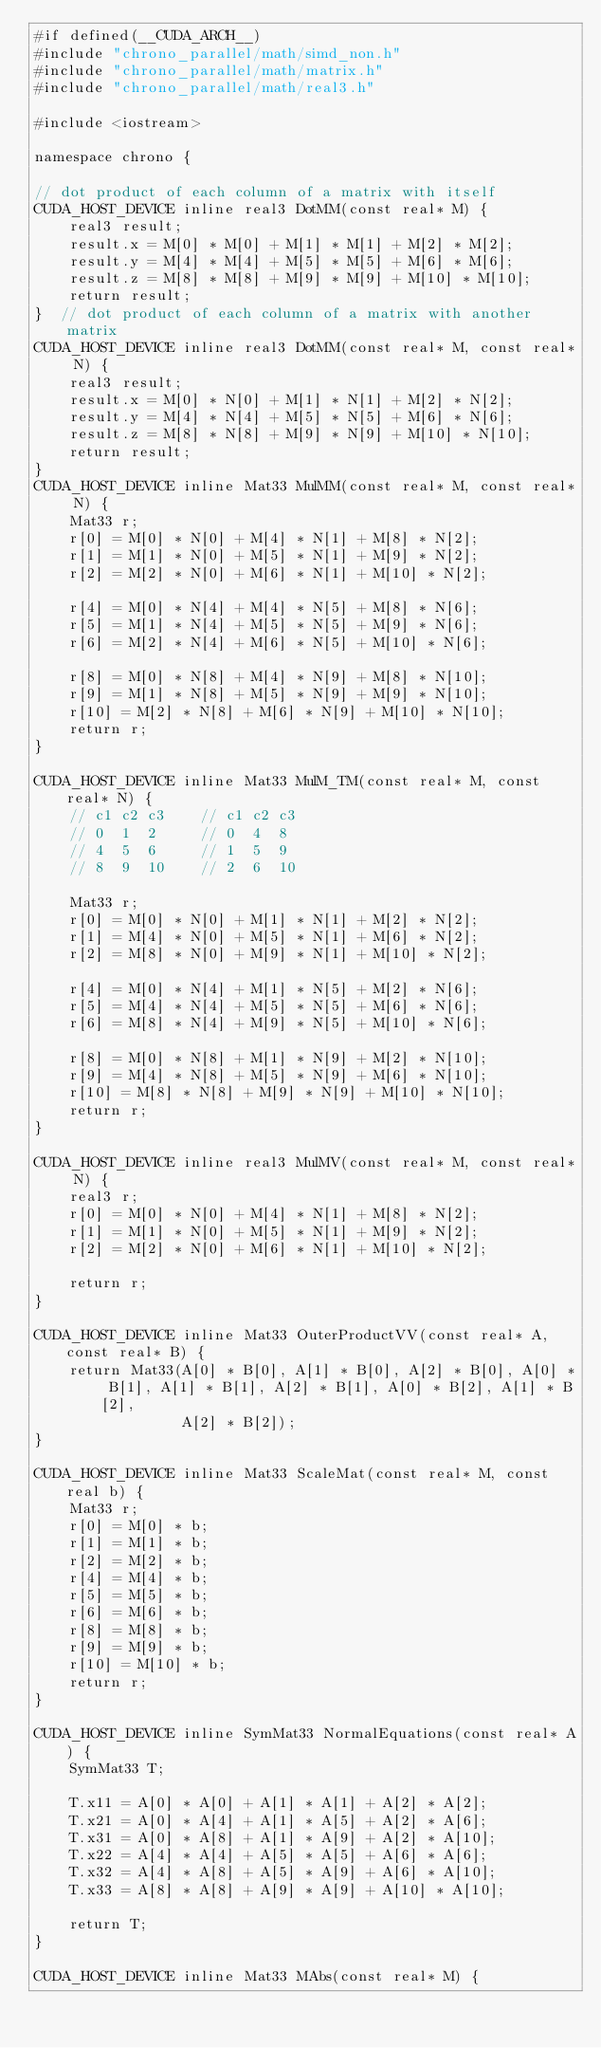<code> <loc_0><loc_0><loc_500><loc_500><_Cuda_>#if defined(__CUDA_ARCH__)
#include "chrono_parallel/math/simd_non.h"
#include "chrono_parallel/math/matrix.h"
#include "chrono_parallel/math/real3.h"

#include <iostream>

namespace chrono {

// dot product of each column of a matrix with itself
CUDA_HOST_DEVICE inline real3 DotMM(const real* M) {
    real3 result;
    result.x = M[0] * M[0] + M[1] * M[1] + M[2] * M[2];
    result.y = M[4] * M[4] + M[5] * M[5] + M[6] * M[6];
    result.z = M[8] * M[8] + M[9] * M[9] + M[10] * M[10];
    return result;
}  // dot product of each column of a matrix with another matrix
CUDA_HOST_DEVICE inline real3 DotMM(const real* M, const real* N) {
    real3 result;
    result.x = M[0] * N[0] + M[1] * N[1] + M[2] * N[2];
    result.y = M[4] * N[4] + M[5] * N[5] + M[6] * N[6];
    result.z = M[8] * N[8] + M[9] * N[9] + M[10] * N[10];
    return result;
}
CUDA_HOST_DEVICE inline Mat33 MulMM(const real* M, const real* N) {
    Mat33 r;
    r[0] = M[0] * N[0] + M[4] * N[1] + M[8] * N[2];
    r[1] = M[1] * N[0] + M[5] * N[1] + M[9] * N[2];
    r[2] = M[2] * N[0] + M[6] * N[1] + M[10] * N[2];

    r[4] = M[0] * N[4] + M[4] * N[5] + M[8] * N[6];
    r[5] = M[1] * N[4] + M[5] * N[5] + M[9] * N[6];
    r[6] = M[2] * N[4] + M[6] * N[5] + M[10] * N[6];

    r[8] = M[0] * N[8] + M[4] * N[9] + M[8] * N[10];
    r[9] = M[1] * N[8] + M[5] * N[9] + M[9] * N[10];
    r[10] = M[2] * N[8] + M[6] * N[9] + M[10] * N[10];
    return r;
}

CUDA_HOST_DEVICE inline Mat33 MulM_TM(const real* M, const real* N) {
    // c1 c2 c3    // c1 c2 c3
    // 0  1  2     // 0  4  8
    // 4  5  6     // 1  5  9
    // 8  9  10    // 2  6  10

    Mat33 r;
    r[0] = M[0] * N[0] + M[1] * N[1] + M[2] * N[2];
    r[1] = M[4] * N[0] + M[5] * N[1] + M[6] * N[2];
    r[2] = M[8] * N[0] + M[9] * N[1] + M[10] * N[2];

    r[4] = M[0] * N[4] + M[1] * N[5] + M[2] * N[6];
    r[5] = M[4] * N[4] + M[5] * N[5] + M[6] * N[6];
    r[6] = M[8] * N[4] + M[9] * N[5] + M[10] * N[6];

    r[8] = M[0] * N[8] + M[1] * N[9] + M[2] * N[10];
    r[9] = M[4] * N[8] + M[5] * N[9] + M[6] * N[10];
    r[10] = M[8] * N[8] + M[9] * N[9] + M[10] * N[10];
    return r;
}

CUDA_HOST_DEVICE inline real3 MulMV(const real* M, const real* N) {
    real3 r;
    r[0] = M[0] * N[0] + M[4] * N[1] + M[8] * N[2];
    r[1] = M[1] * N[0] + M[5] * N[1] + M[9] * N[2];
    r[2] = M[2] * N[0] + M[6] * N[1] + M[10] * N[2];

    return r;
}

CUDA_HOST_DEVICE inline Mat33 OuterProductVV(const real* A, const real* B) {
    return Mat33(A[0] * B[0], A[1] * B[0], A[2] * B[0], A[0] * B[1], A[1] * B[1], A[2] * B[1], A[0] * B[2], A[1] * B[2],
                 A[2] * B[2]);
}

CUDA_HOST_DEVICE inline Mat33 ScaleMat(const real* M, const real b) {
    Mat33 r;
    r[0] = M[0] * b;
    r[1] = M[1] * b;
    r[2] = M[2] * b;
    r[4] = M[4] * b;
    r[5] = M[5] * b;
    r[6] = M[6] * b;
    r[8] = M[8] * b;
    r[9] = M[9] * b;
    r[10] = M[10] * b;
    return r;
}

CUDA_HOST_DEVICE inline SymMat33 NormalEquations(const real* A) {
    SymMat33 T;

    T.x11 = A[0] * A[0] + A[1] * A[1] + A[2] * A[2];
    T.x21 = A[0] * A[4] + A[1] * A[5] + A[2] * A[6];
    T.x31 = A[0] * A[8] + A[1] * A[9] + A[2] * A[10];
    T.x22 = A[4] * A[4] + A[5] * A[5] + A[6] * A[6];
    T.x32 = A[4] * A[8] + A[5] * A[9] + A[6] * A[10];
    T.x33 = A[8] * A[8] + A[9] * A[9] + A[10] * A[10];

    return T;
}

CUDA_HOST_DEVICE inline Mat33 MAbs(const real* M) {</code> 